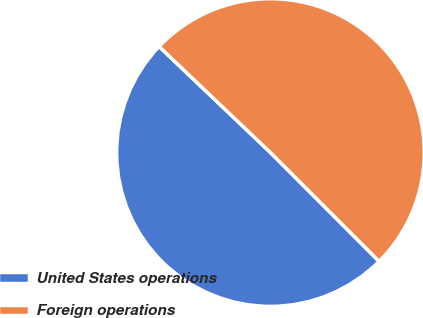Convert chart to OTSL. <chart><loc_0><loc_0><loc_500><loc_500><pie_chart><fcel>United States operations<fcel>Foreign operations<nl><fcel>49.6%<fcel>50.4%<nl></chart> 